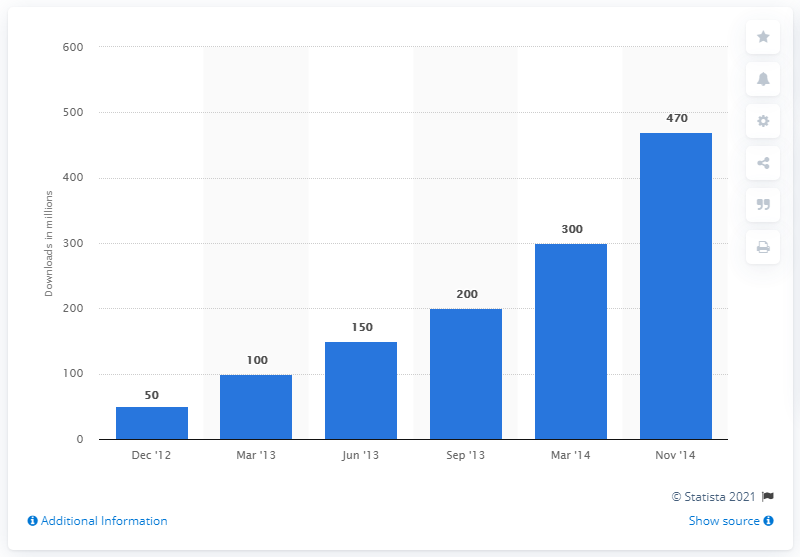List a handful of essential elements in this visual. In March 2014, LINE's gaming platform reported that 300 apps were downloaded. During the period of December 2012 and November 2014, a total of 470 apps were downloaded from the LINE Game app store. 